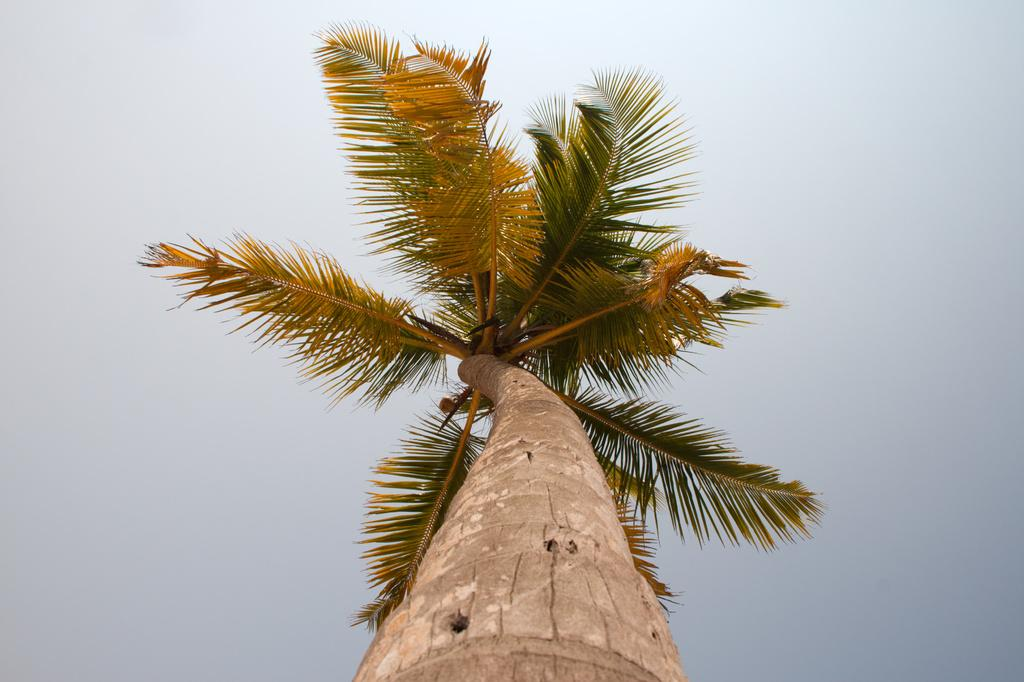What is the main subject in the center of the image? There is a tree in the center of the image. What can be seen in the background of the image? The sky in the background is cloudy. How many trucks are parked near the tree in the image? There are no trucks present in the image; it only features a tree and a cloudy sky. Can you see any feet in the image? There are no feet visible in the image; it only features a tree and a cloudy sky. 